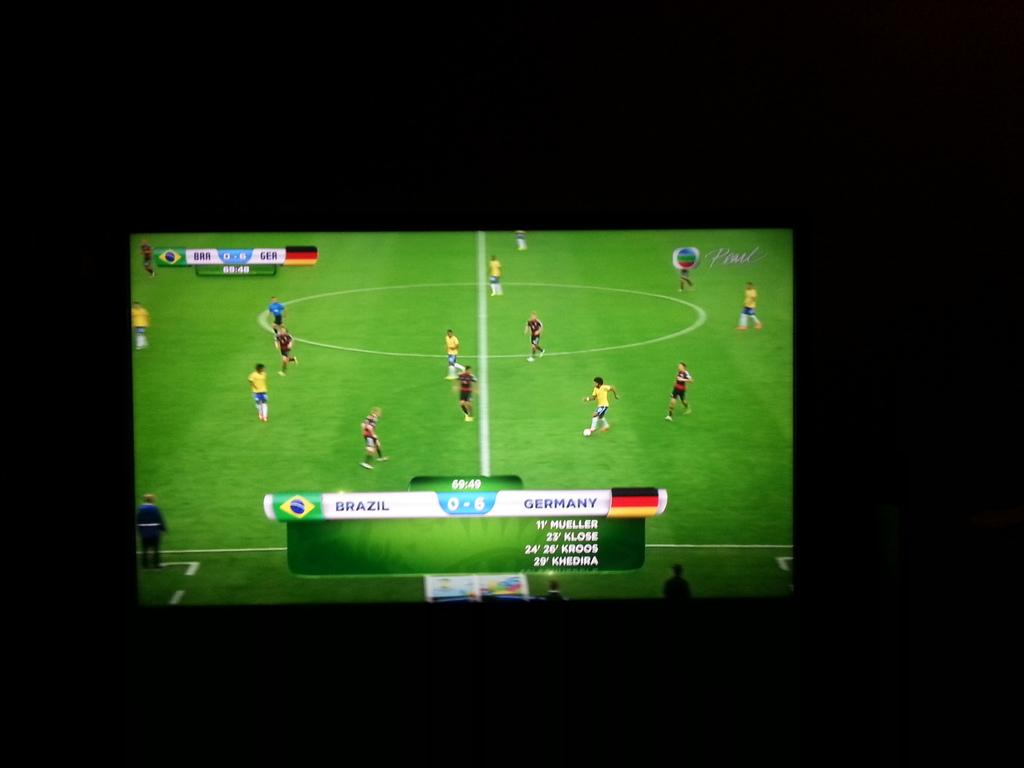Provide a one-sentence caption for the provided image. A soccer match between Brazil and Germany is on a television. 